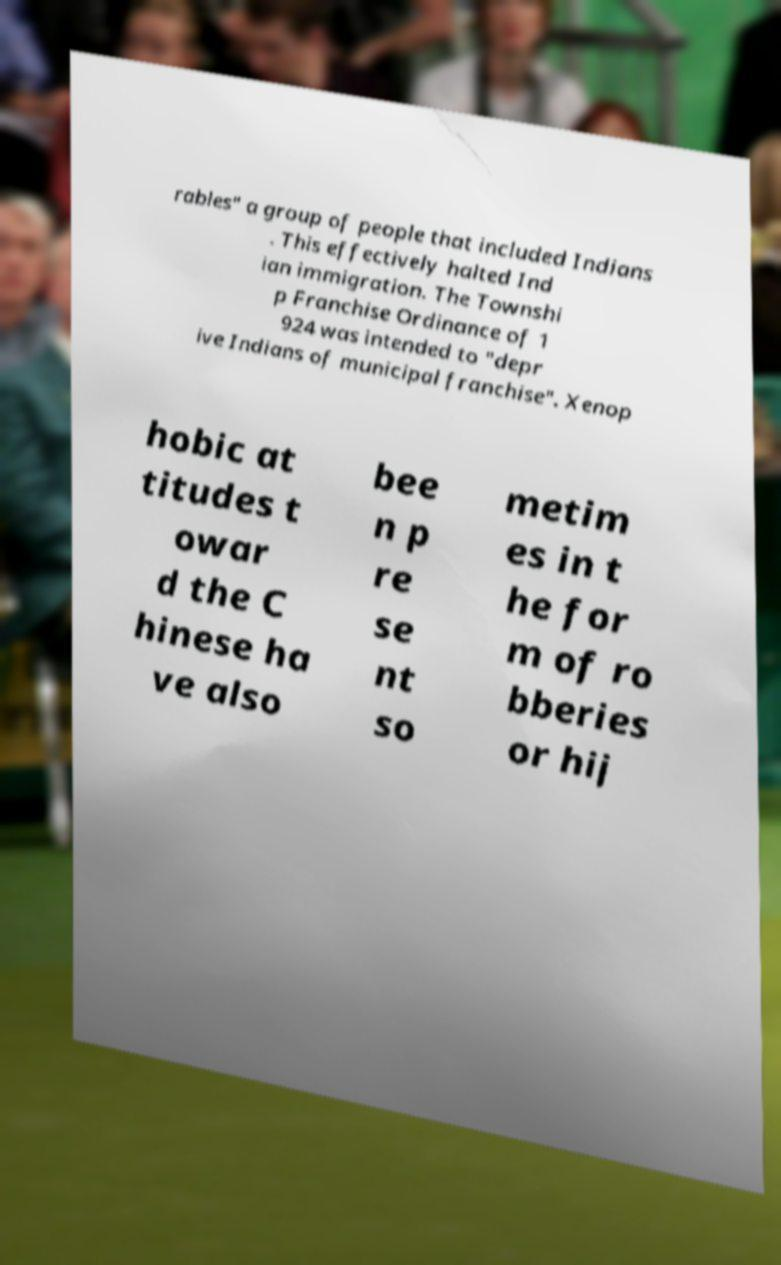Can you read and provide the text displayed in the image?This photo seems to have some interesting text. Can you extract and type it out for me? rables" a group of people that included Indians . This effectively halted Ind ian immigration. The Townshi p Franchise Ordinance of 1 924 was intended to "depr ive Indians of municipal franchise". Xenop hobic at titudes t owar d the C hinese ha ve also bee n p re se nt so metim es in t he for m of ro bberies or hij 